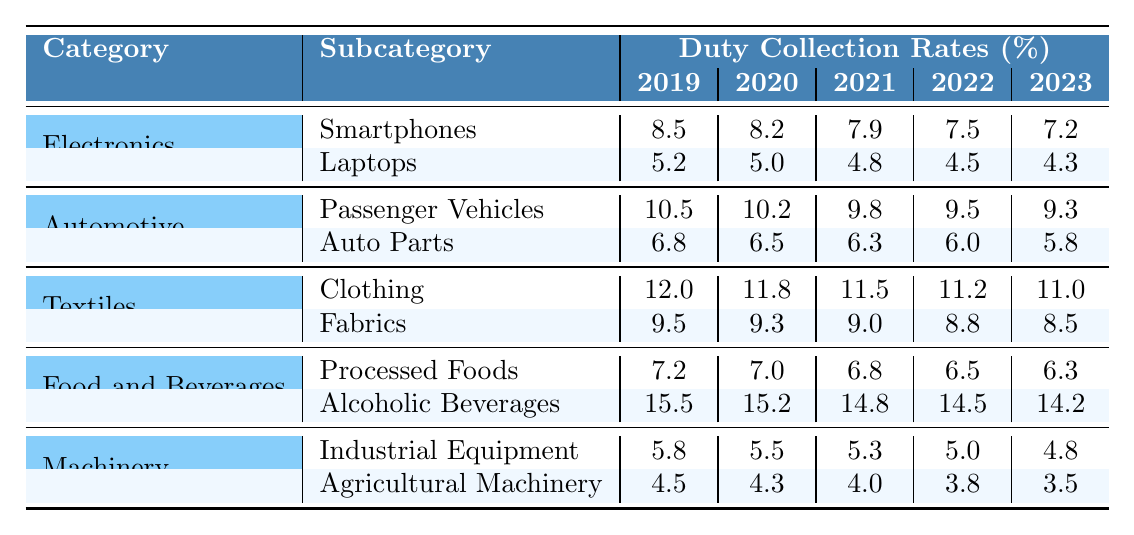What was the duty collection rate for Smartphones in 2021? Referring to the "Electronics" category and the "Smartphones" subcategory, the duty collection rate for 2021 is 7.9%.
Answer: 7.9% Which commodity category had the highest duty collection rate in 2019? The "Textiles" category with "Clothing" had the highest duty collection rate of 12.0% in 2019.
Answer: Textiles (Clothing) What is the difference in duty collection rates for Auto Parts between 2019 and 2023? The rate for Auto Parts in 2019 is 6.8%, and in 2023 it is 5.8%. The difference is 6.8% - 5.8% = 1.0%.
Answer: 1.0% What is the average duty collection rate for Agricultural Machinery over the last five years? The rates are 4.5%, 4.3%, 4.0%, 3.8%, and 3.5%. The sum is 20.1%, and dividing by 5 gives an average of 4.02%.
Answer: 4.02% Which subcategory in Food and Beverages saw a decrease from 2019 to 2023? Processed Foods decreased from 7.2% in 2019 to 6.3% in 2023, while Alcoholic Beverages decreased from 15.5% to 14.2%. Thus, both subcategories showed a decrease.
Answer: Yes Is the duty collection rate for Laptops lower than that for Industrial Equipment in 2023? The duty collection rate for Laptops in 2023 is 4.3%, and for Industrial Equipment, it is 4.8%. Therefore, Laptops have a lower rate.
Answer: Yes What was the overall trend in duty collection rates for Clothing from 2019 to 2023? The rates for Clothing were 12.0%, 11.8%, 11.5%, 11.2%, and 11.0%, showing a downward trend over the years.
Answer: Downward trend What is the total duty collection rate for all subcategories under the Automotive category in 2022? The rates are 9.5% for Passenger Vehicles and 6.0% for Auto Parts. Summing these gives 9.5% + 6.0% = 15.5%.
Answer: 15.5% Which subcategory had the largest duty collection rate decrease from 2020 to 2023? Analyzing the decreases: Auto Parts (0.7%), Agricultural Machinery (0.8%), and Alcoholic Beverages (0.8%) decreased the most, showing a tie.
Answer: Auto Parts and Alcoholic Beverages (0.8% decrease) In which year did Passenger Vehicles have a duty collection rate of 9.8%? This rate is recorded for Passenger Vehicles in the year 2021.
Answer: 2021 What is the total duty collection rate for the Electronics category in 2023? The rates are 7.2% for Smartphones and 4.3% for Laptops. The total is 7.2% + 4.3% = 11.5%.
Answer: 11.5% 